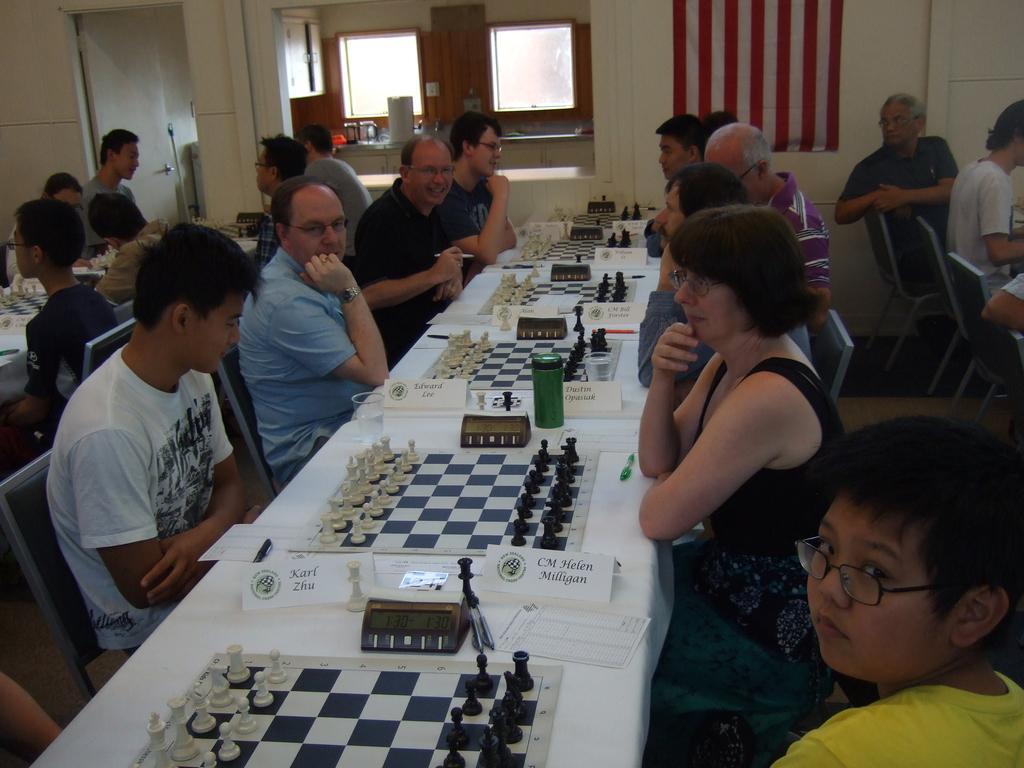Could you give a brief overview of what you see in this image? As we can see in the image there is a window, flag, wall, few people sitting here and there and chairs and tables. On table there is chess boards and coins. 